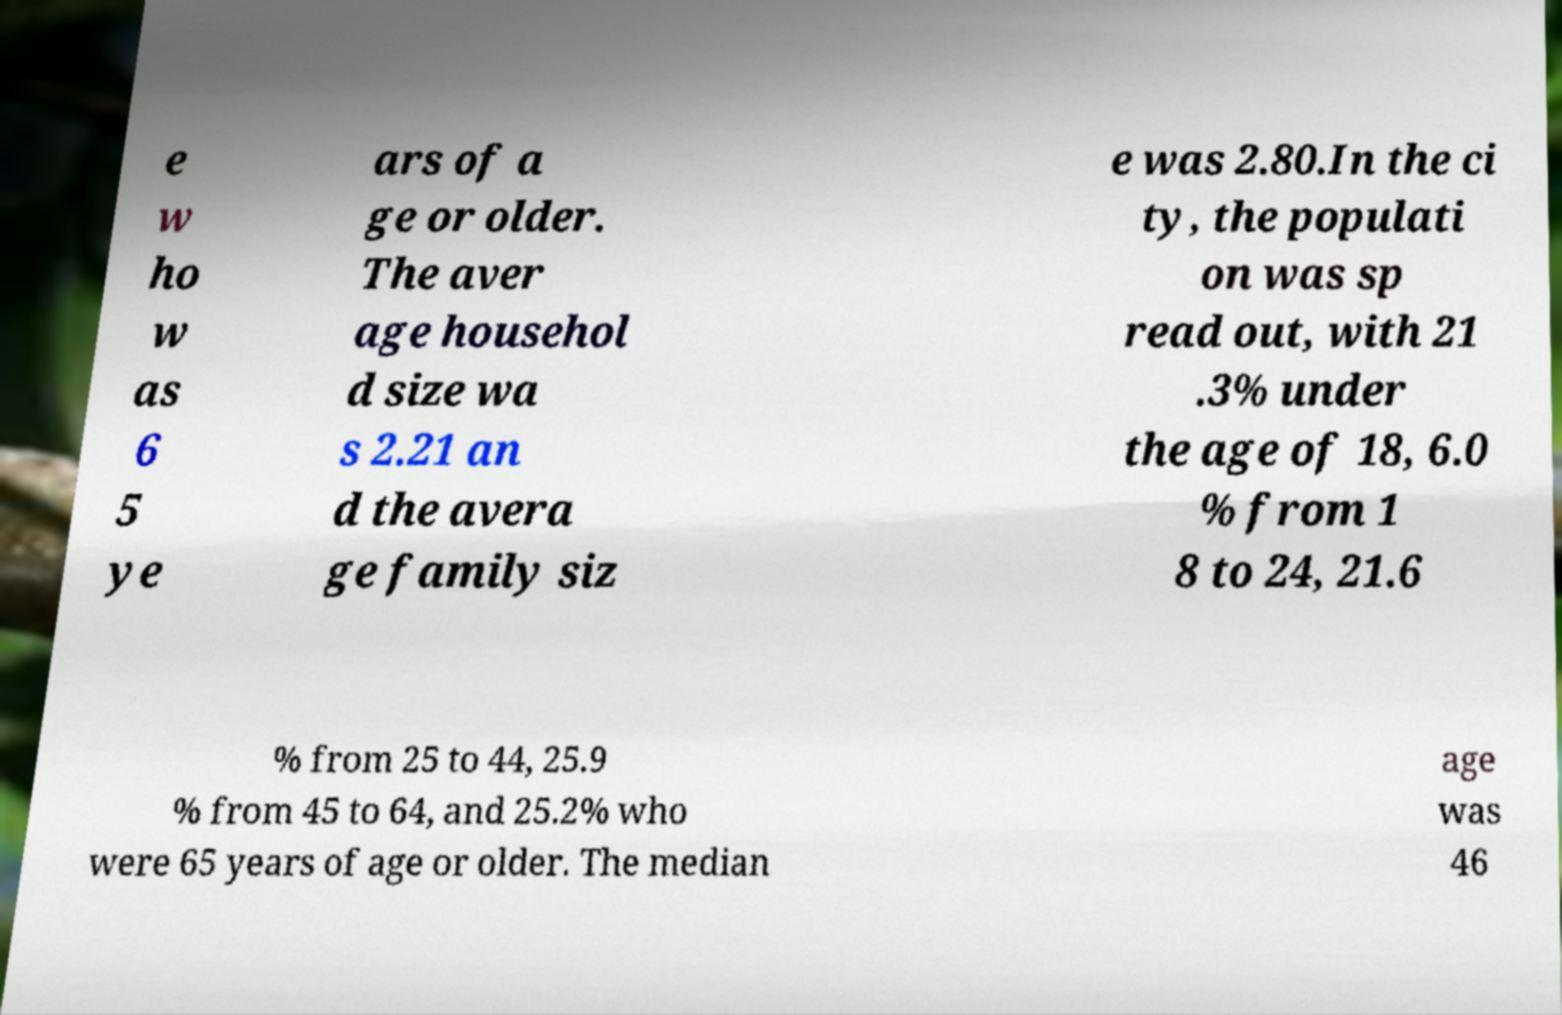Can you read and provide the text displayed in the image?This photo seems to have some interesting text. Can you extract and type it out for me? e w ho w as 6 5 ye ars of a ge or older. The aver age househol d size wa s 2.21 an d the avera ge family siz e was 2.80.In the ci ty, the populati on was sp read out, with 21 .3% under the age of 18, 6.0 % from 1 8 to 24, 21.6 % from 25 to 44, 25.9 % from 45 to 64, and 25.2% who were 65 years of age or older. The median age was 46 